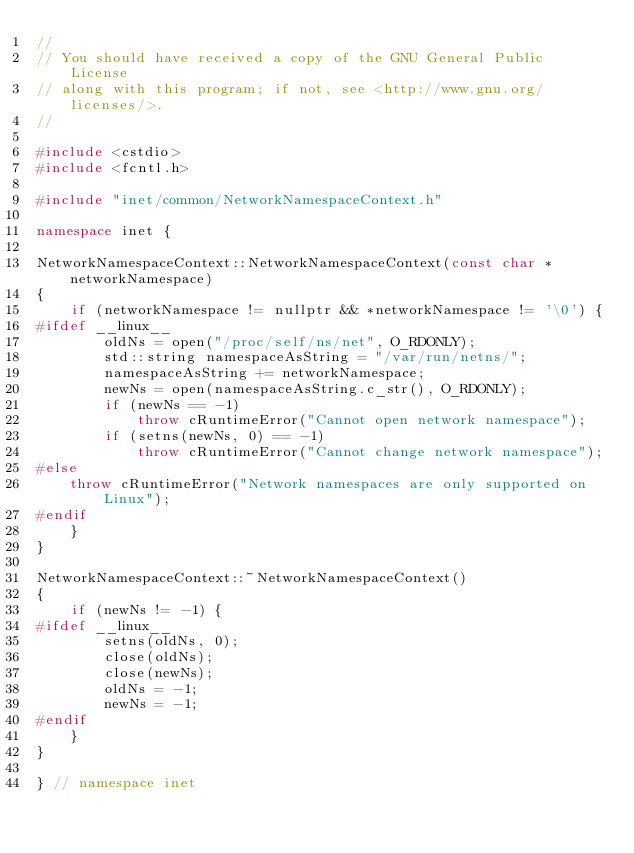<code> <loc_0><loc_0><loc_500><loc_500><_C++_>//
// You should have received a copy of the GNU General Public License
// along with this program; if not, see <http://www.gnu.org/licenses/>.
//

#include <cstdio>
#include <fcntl.h>

#include "inet/common/NetworkNamespaceContext.h"

namespace inet {

NetworkNamespaceContext::NetworkNamespaceContext(const char *networkNamespace)
{
    if (networkNamespace != nullptr && *networkNamespace != '\0') {
#ifdef __linux__
        oldNs = open("/proc/self/ns/net", O_RDONLY);
        std::string namespaceAsString = "/var/run/netns/";
        namespaceAsString += networkNamespace;
        newNs = open(namespaceAsString.c_str(), O_RDONLY);
        if (newNs == -1)
            throw cRuntimeError("Cannot open network namespace");
        if (setns(newNs, 0) == -1)
            throw cRuntimeError("Cannot change network namespace");
#else
    throw cRuntimeError("Network namespaces are only supported on Linux");
#endif
    }
}

NetworkNamespaceContext::~NetworkNamespaceContext()
{
    if (newNs != -1) {
#ifdef __linux__
        setns(oldNs, 0);
        close(oldNs);
        close(newNs);
        oldNs = -1;
        newNs = -1;
#endif
    }
}

} // namespace inet

</code> 